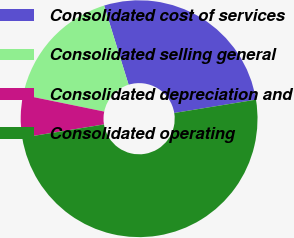Convert chart. <chart><loc_0><loc_0><loc_500><loc_500><pie_chart><fcel>Consolidated cost of services<fcel>Consolidated selling general<fcel>Consolidated depreciation and<fcel>Consolidated operating<nl><fcel>27.2%<fcel>17.01%<fcel>5.78%<fcel>50.0%<nl></chart> 